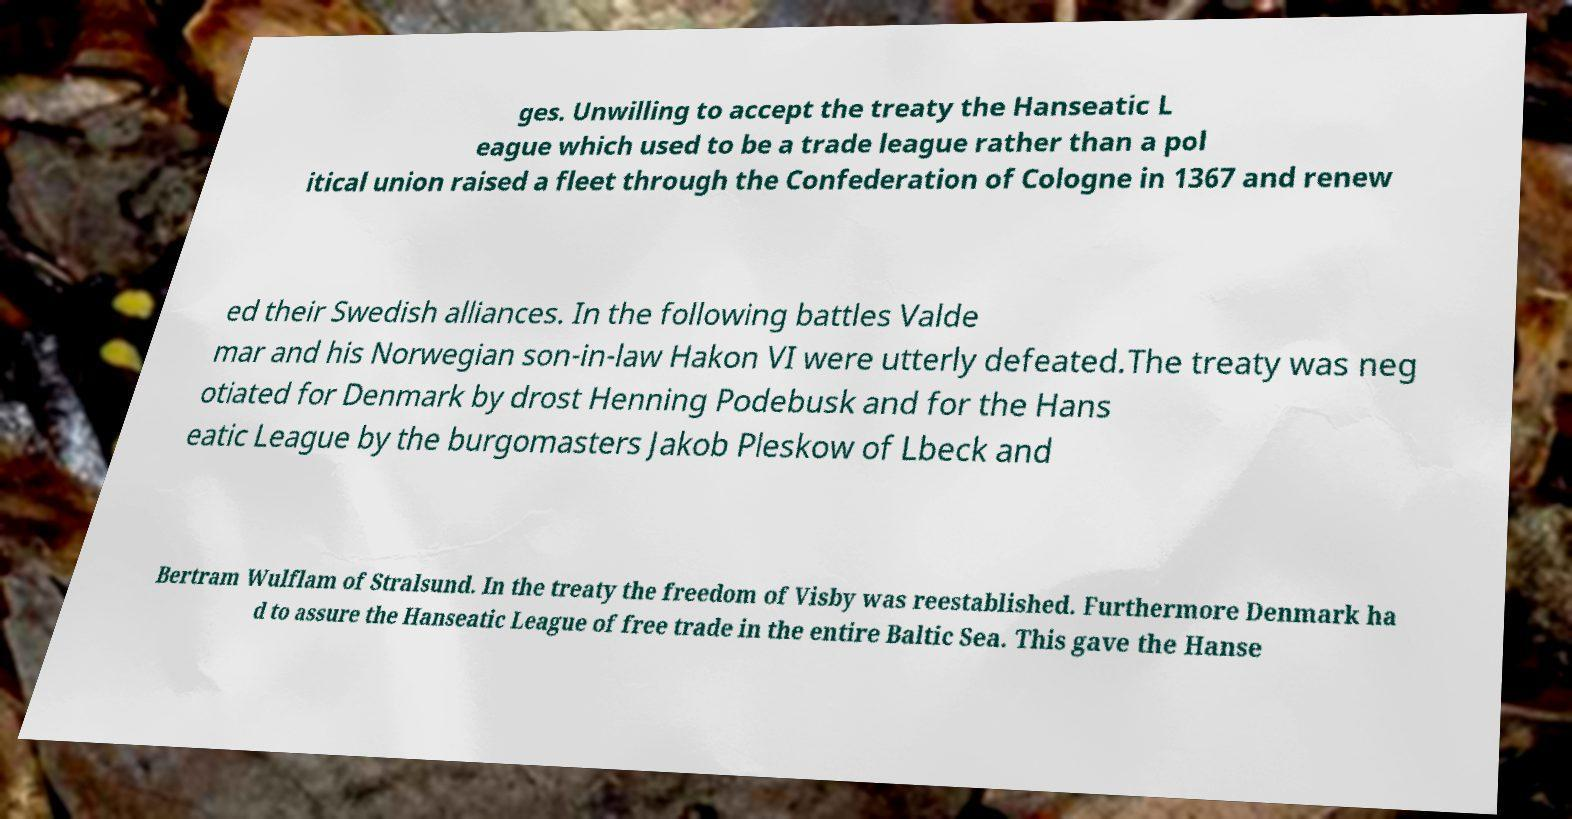Could you extract and type out the text from this image? ges. Unwilling to accept the treaty the Hanseatic L eague which used to be a trade league rather than a pol itical union raised a fleet through the Confederation of Cologne in 1367 and renew ed their Swedish alliances. In the following battles Valde mar and his Norwegian son-in-law Hakon VI were utterly defeated.The treaty was neg otiated for Denmark by drost Henning Podebusk and for the Hans eatic League by the burgomasters Jakob Pleskow of Lbeck and Bertram Wulflam of Stralsund. In the treaty the freedom of Visby was reestablished. Furthermore Denmark ha d to assure the Hanseatic League of free trade in the entire Baltic Sea. This gave the Hanse 